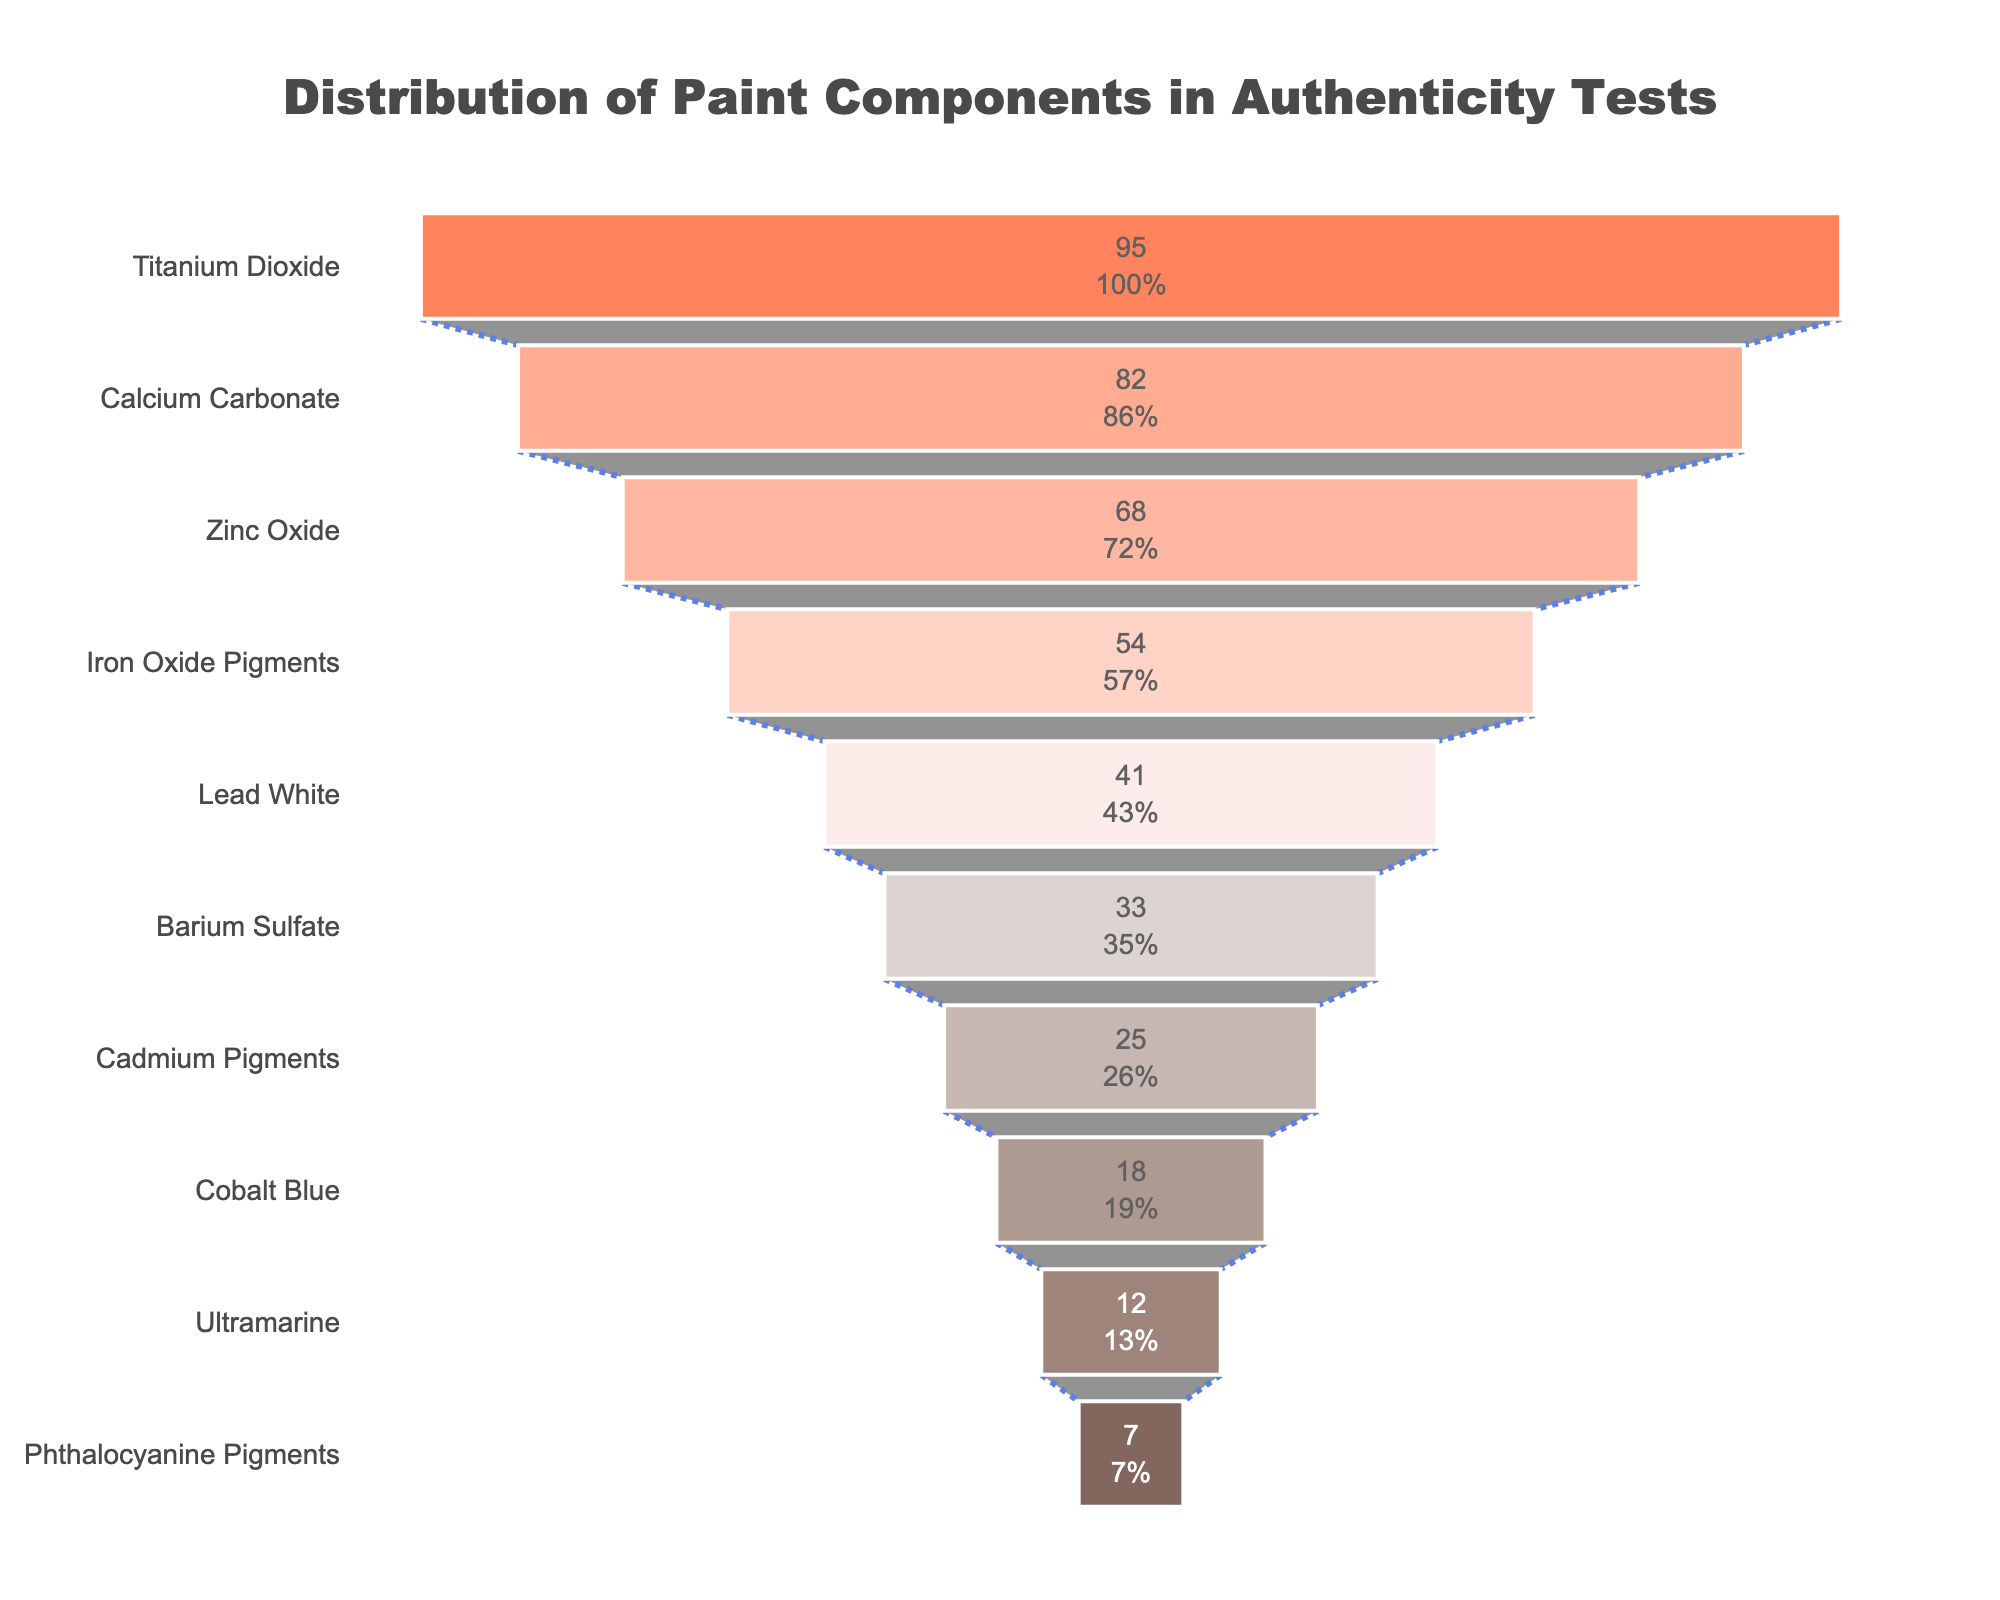what is the most common paint component? According to the chart, the component with the highest frequency is at the top of the funnel.
Answer: Titanium Dioxide What percentage does Titanium Dioxide make up of all components tested? The figure shows the value and percent of the initial for each component. Look for the percentage next to Titanium Dioxide.
Answer: 26% How many paint components have a frequency greater than 50? Identify the components with frequencies higher than 50 by looking at their respective values in the chart. There are three: Titanium Dioxide (95), Calcium Carbonate (82), and Zinc Oxide (68).
Answer: 3 What is the combined frequency of Barium Sulfate and Cadmium Pigments? Add the frequencies of Barium Sulfate (33) and Cadmium Pigments (25).
Answer: 58 Is Lead White more common than Barium Sulfate? Compare the frequency of Lead White (41) with that of Barium Sulfate (33). Lead White has a higher frequency.
Answer: Yes Which has the least frequency: Ultramarine or Phthalocyanine Pigments? Check the values for both Ultramarine and Phthalocyanine Pigments. Phthalocyanine Pigments has a frequency of 7, which is less than Ultramarine's 12.
Answer: Phthalocyanine Pigments What is the difference in frequency between Iron Oxide Pigments and Cobalt Blue? Subtract the frequency of Cobalt Blue (18) from that of Iron Oxide Pigments (54).
Answer: 36 How many components have a frequency less than 20? Identify the components with frequencies below 20: Cobalt Blue (18), Ultramarine (12), and Phthalocyanine Pigments (7). There are three components.
Answer: 3 Which component has the third-highest frequency? The funnel chart orders components by frequency from most to least. The third-highest is Zinc Oxide with a frequency of 68.
Answer: Zinc Oxide What is the total frequency of all the components? Sum the frequencies: 95 + 82 + 68 + 54 + 41 + 33 + 25 + 18 + 12 + 7 = 435.
Answer: 435 